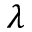Convert formula to latex. <formula><loc_0><loc_0><loc_500><loc_500>\lambda</formula> 